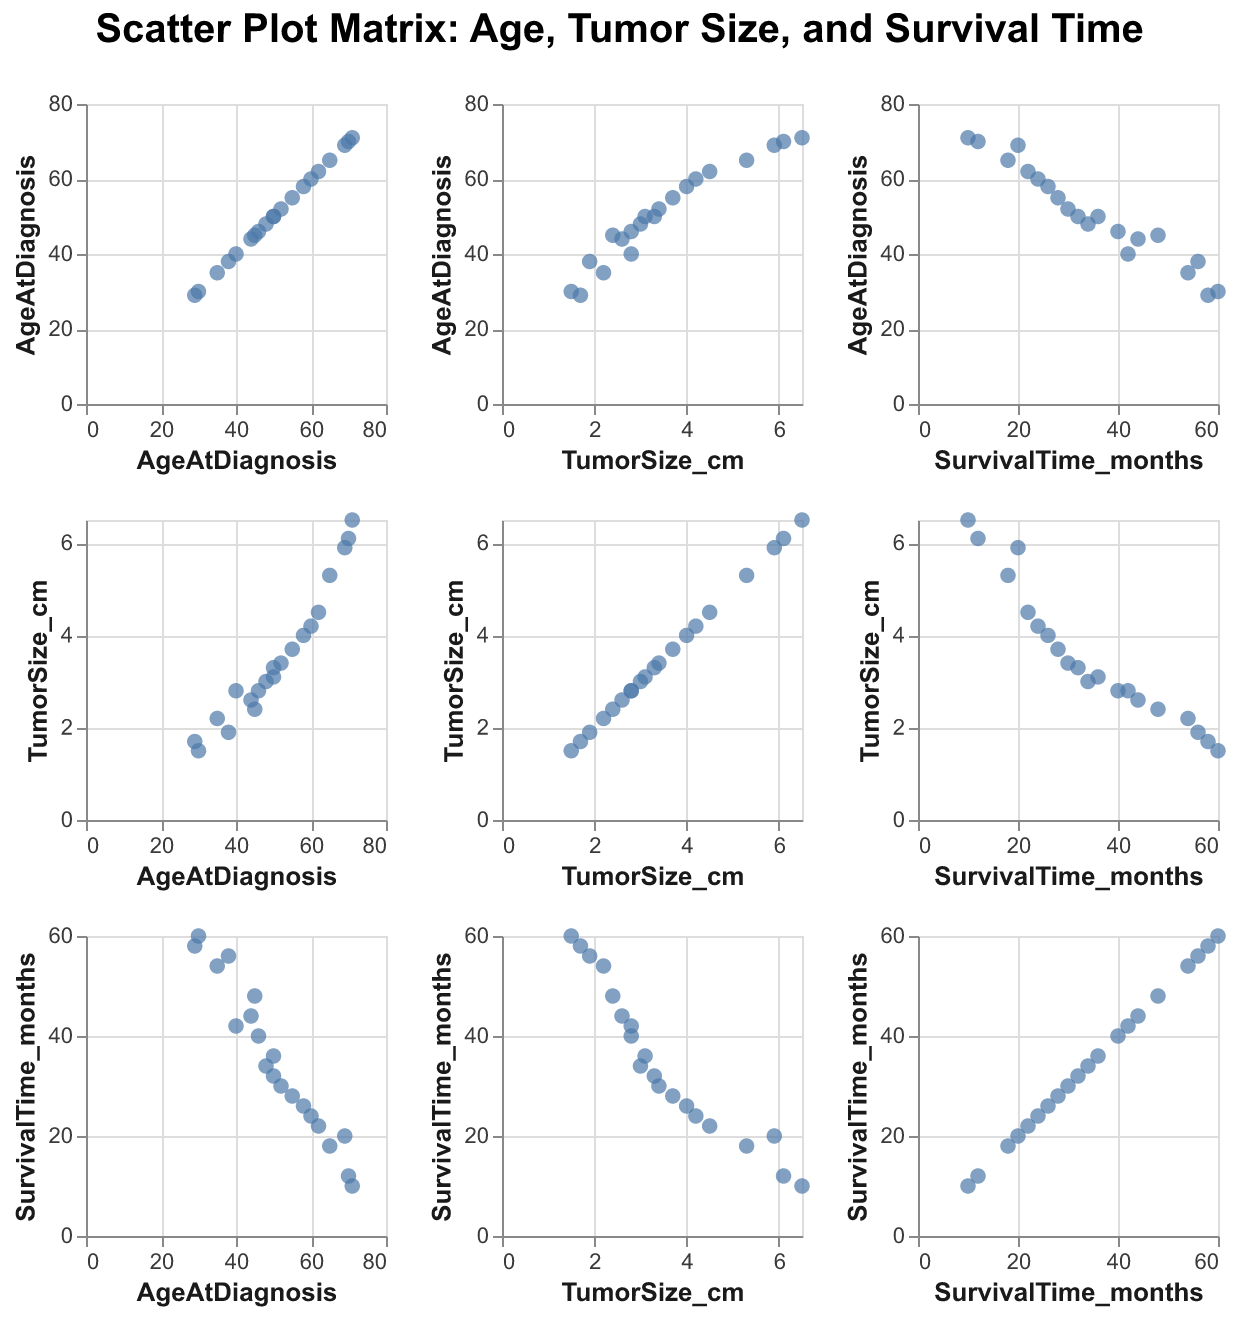How many patients have their ages at diagnosis displayed in the figure? There are 20 data points in the scatter plot matrix, each representing a unique patient. By counting the data points for "AgeAtDiagnosis" in the figure, we confirm there are 20.
Answer: 20 What is the title of the scatter plot matrix? The title is displayed at the top of the figure, indicating the key variables and the relationship being explored.
Answer: Scatter Plot Matrix: Age, Tumor Size, and Survival Time Which axis displays "TumorSize_cm"? "TumorSize_cm" is shown on both the x-axis and y-axis in various plots within the matrix. You see it by looking at the axis labels.
Answer: x-axis and y-axis Is there a correlation between age at diagnosis and tumor size? By observing the scatter plot comparing "AgeAtDiagnosis" and "TumorSize_cm", one can infer the presence of a noticeable trend or lack thereof. The plotted points do not show a strong linear relationship, suggesting weak or no correlation.
Answer: Weak or no correlation Which age group tends to have larger tumor sizes? By examining the scatter plot of "AgeAtDiagnosis" vs. "TumorSize_cm", it can be observed that older patients (ages 60 and above) tend to have larger tumor sizes compared to younger patients.
Answer: Older patients (ages 60+) How does survival time compare between patients with tumor sizes greater than 4 cm and those with smaller tumors? By looking at the scatter plot of "TumorSize_cm" vs. "SurvivalTime_months", it is evident that patients with tumor sizes greater than 4 cm have generally lower survival times compared to those with smaller tumors.
Answer: Lower survival times for larger tumors What can be inferred about the survival time for patients diagnosed at an older age? Referencing the scatter plot of "AgeAtDiagnosis" vs. "SurvivalTime_months", it becomes noticeable that older patients tend to have shorter survival times when compared to younger patients.
Answer: Shorter survival times for older patients Identify the data point with the highest tumor size and state its survival time. In the "TumorSize_cm" vs. "SurvivalTime_months" scatter plot, the point with the highest tumor size (6.5 cm) corresponds to PatientID P020, who has a survival time of 10 months.
Answer: 10 months Which patient has the longest survival time, and what are their age and tumor size? In the "SurvivalTime_months" plot, the longest survival time (60 months) is seen for PatientID P004, whose age at diagnosis is 30 and tumor size is 1.5 cm.
Answer: Age: 30, Tumor Size: 1.5 cm 